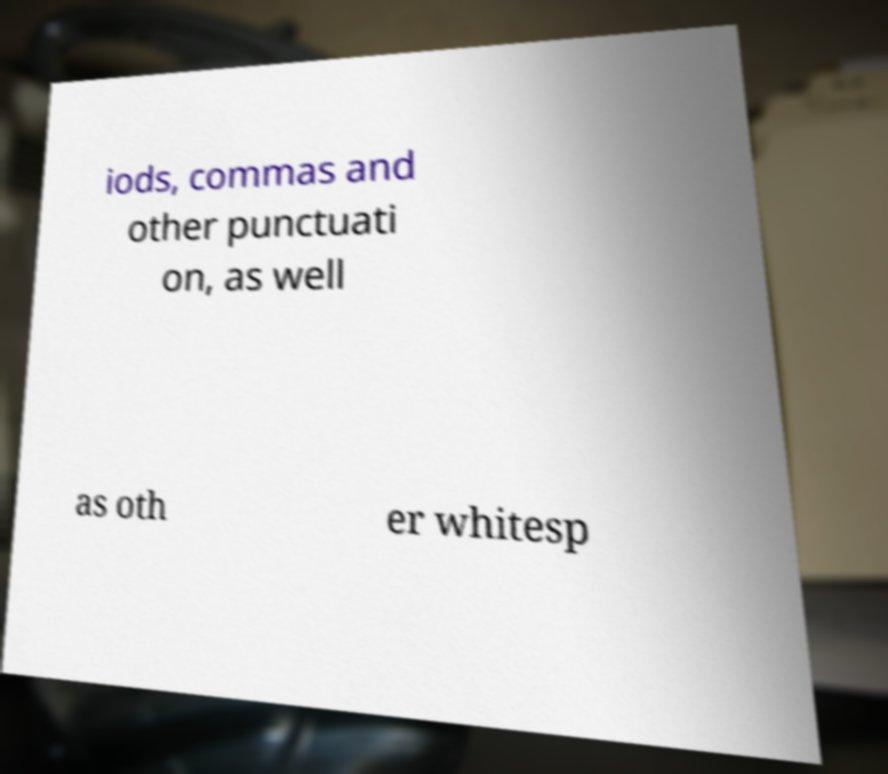Could you assist in decoding the text presented in this image and type it out clearly? iods, commas and other punctuati on, as well as oth er whitesp 